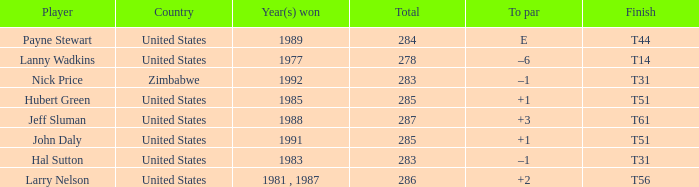What is Country, when Total is greater than 283, and when Year(s) Won is "1989"? United States. Would you mind parsing the complete table? {'header': ['Player', 'Country', 'Year(s) won', 'Total', 'To par', 'Finish'], 'rows': [['Payne Stewart', 'United States', '1989', '284', 'E', 'T44'], ['Lanny Wadkins', 'United States', '1977', '278', '–6', 'T14'], ['Nick Price', 'Zimbabwe', '1992', '283', '–1', 'T31'], ['Hubert Green', 'United States', '1985', '285', '+1', 'T51'], ['Jeff Sluman', 'United States', '1988', '287', '+3', 'T61'], ['John Daly', 'United States', '1991', '285', '+1', 'T51'], ['Hal Sutton', 'United States', '1983', '283', '–1', 'T31'], ['Larry Nelson', 'United States', '1981 , 1987', '286', '+2', 'T56']]} 